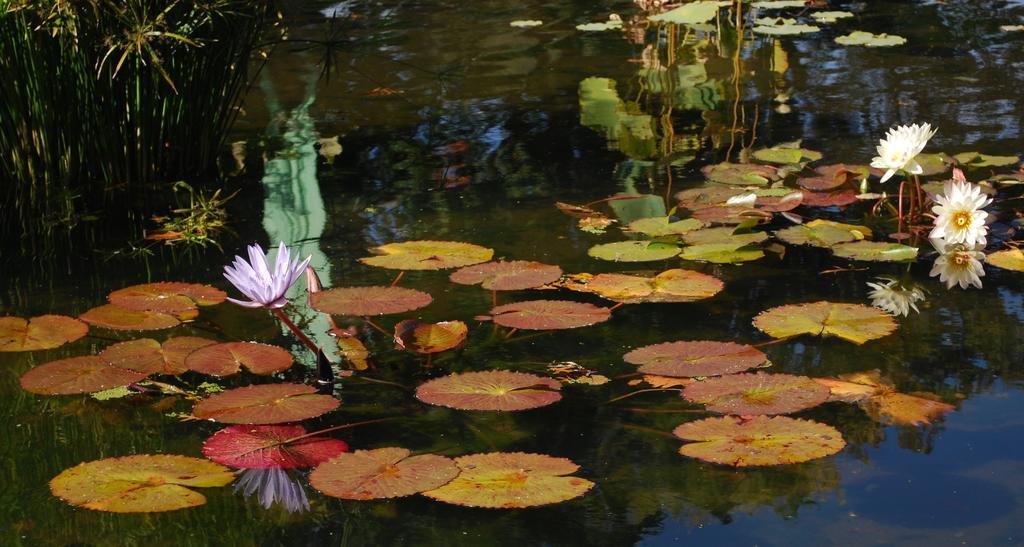Can you describe this image briefly? In this image we can see flowers, leaves and plants in a water. 